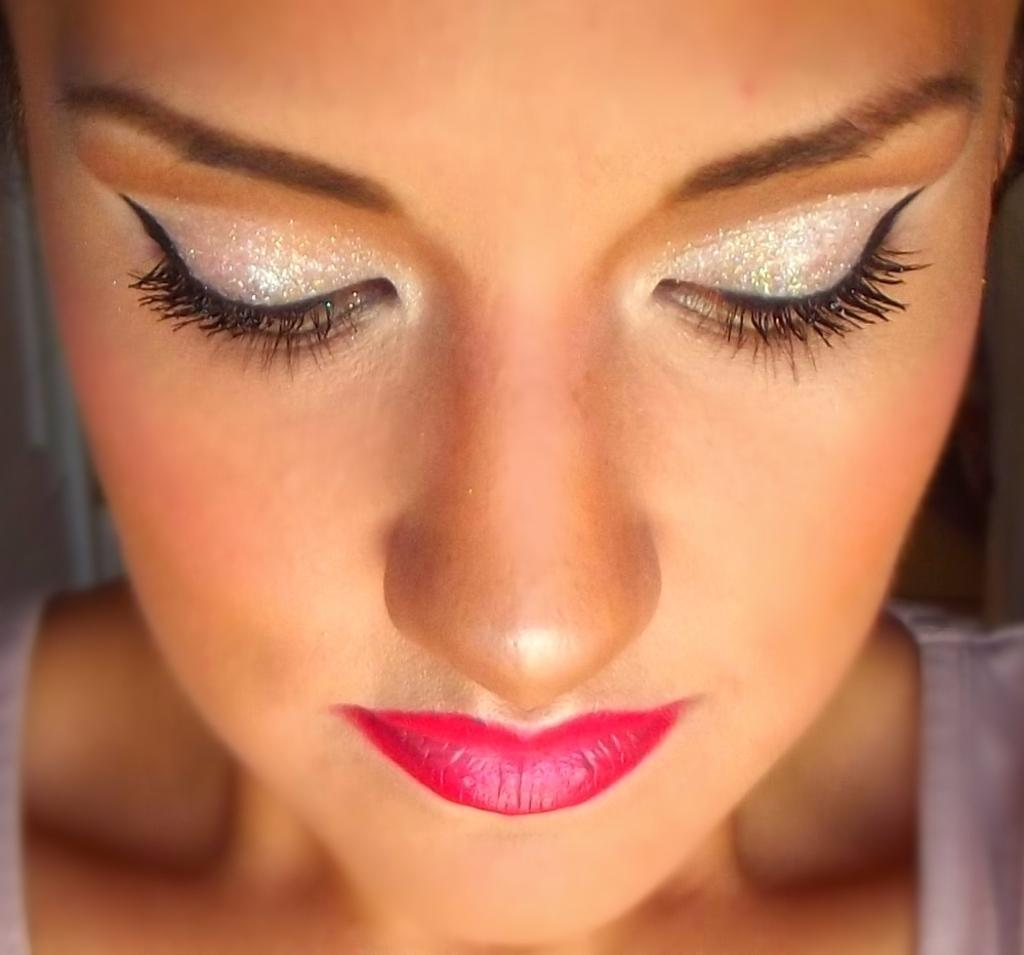What is the main subject of the image? There is a person's face in the image. What feature stands out on the person's face? The person has red lips. Are there any other noticeable features on the person's face? Yes, the person has eyeliner. What type of government is depicted in the image? There is no government depicted in the image; it features a person's face with red lips and eyeliner. Can you tell me how often the person in the image visits the doctor? There is no information about the person's medical history or visits to the doctor in the image. 